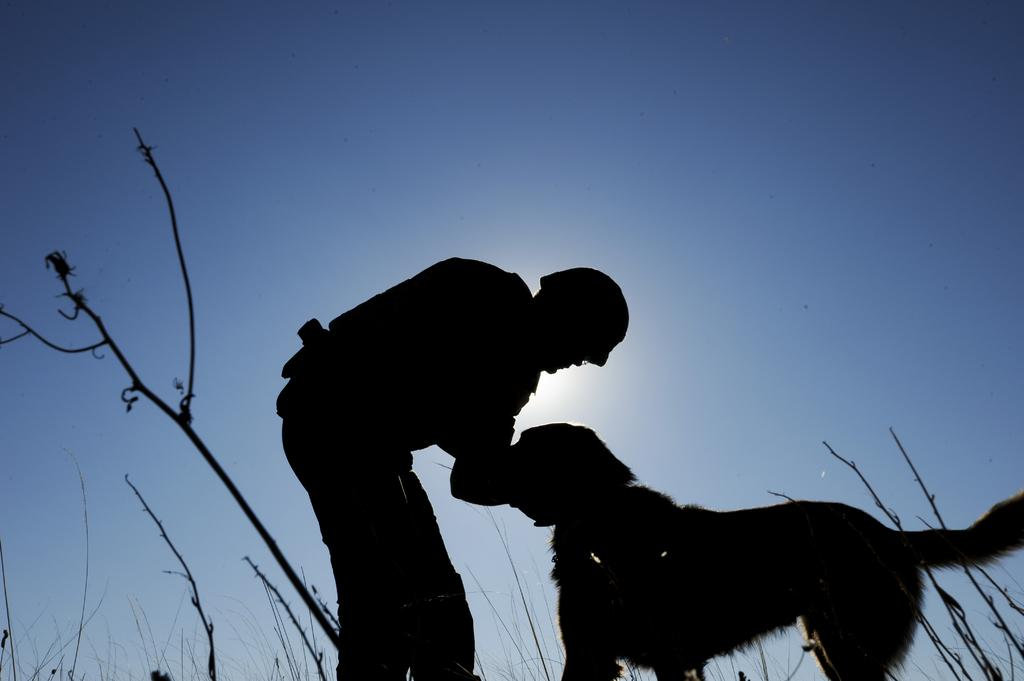Who is present in the image? There is a man in the image. What other living creature is present in the image? There is a dog in the image. What type of vegetation can be seen in the image? Plants are visible in the image. What color is the sky in the image? The sky is blue in the image. What type of cherries can be seen in the image? There are no cherries present in the image. What sound does the wrench make in the image? There is no wrench present in the image, so it cannot make any sound. 